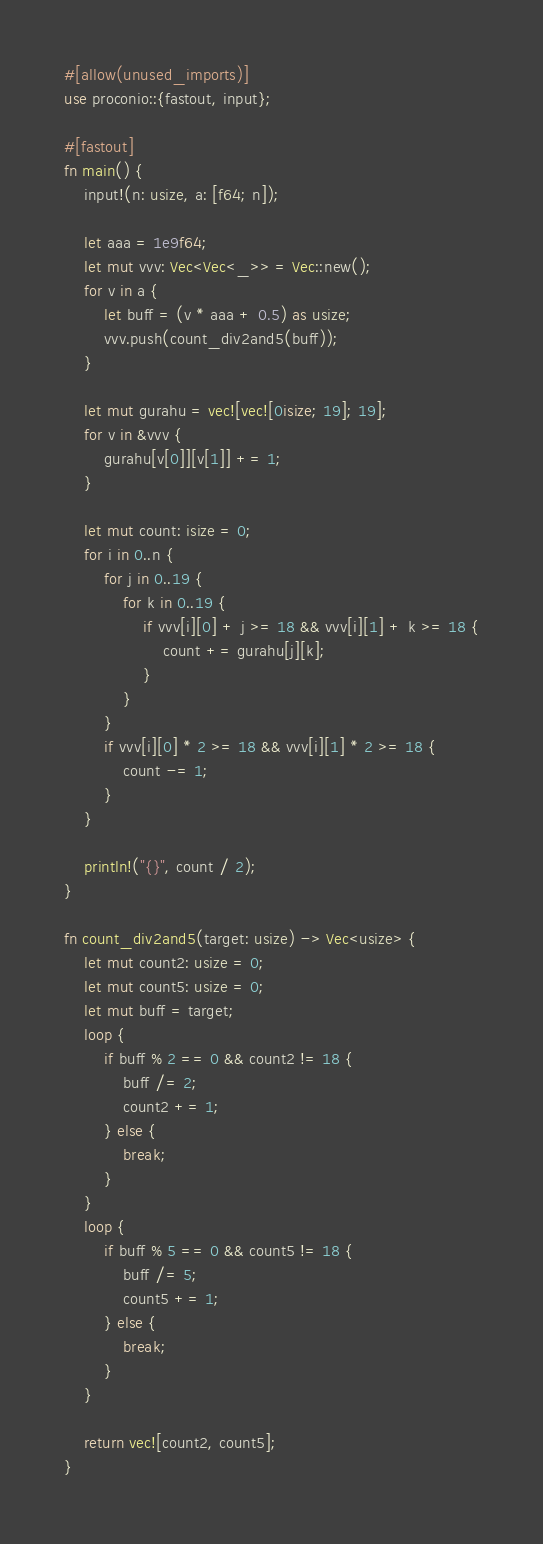Convert code to text. <code><loc_0><loc_0><loc_500><loc_500><_Rust_>#[allow(unused_imports)]
use proconio::{fastout, input};

#[fastout]
fn main() {
    input!(n: usize, a: [f64; n]);

    let aaa = 1e9f64;
    let mut vvv: Vec<Vec<_>> = Vec::new();
    for v in a {
        let buff = (v * aaa + 0.5) as usize;
        vvv.push(count_div2and5(buff));
    }

    let mut gurahu = vec![vec![0isize; 19]; 19];
    for v in &vvv {
        gurahu[v[0]][v[1]] += 1;
    }

    let mut count: isize = 0;
    for i in 0..n {
        for j in 0..19 {
            for k in 0..19 {
                if vvv[i][0] + j >= 18 && vvv[i][1] + k >= 18 {
                    count += gurahu[j][k];
                }
            }
        }
        if vvv[i][0] * 2 >= 18 && vvv[i][1] * 2 >= 18 {
            count -= 1;
        }
    }

    println!("{}", count / 2);
}

fn count_div2and5(target: usize) -> Vec<usize> {
    let mut count2: usize = 0;
    let mut count5: usize = 0;
    let mut buff = target;
    loop {
        if buff % 2 == 0 && count2 != 18 {
            buff /= 2;
            count2 += 1;
        } else {
            break;
        }
    }
    loop {
        if buff % 5 == 0 && count5 != 18 {
            buff /= 5;
            count5 += 1;
        } else {
            break;
        }
    }

    return vec![count2, count5];
}
</code> 